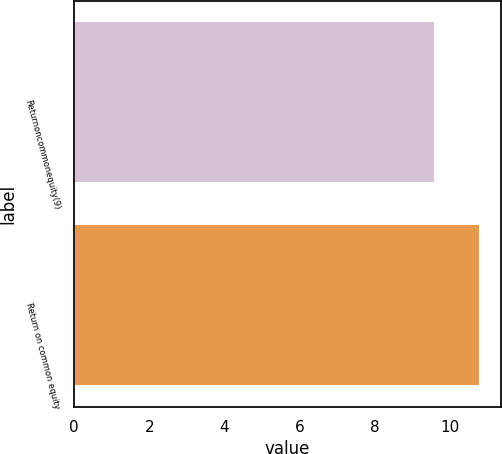Convert chart to OTSL. <chart><loc_0><loc_0><loc_500><loc_500><bar_chart><fcel>Returnoncommonequity(9)<fcel>Return on common equity<nl><fcel>9.6<fcel>10.8<nl></chart> 